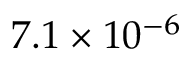Convert formula to latex. <formula><loc_0><loc_0><loc_500><loc_500>7 . 1 \times 1 0 ^ { - 6 }</formula> 